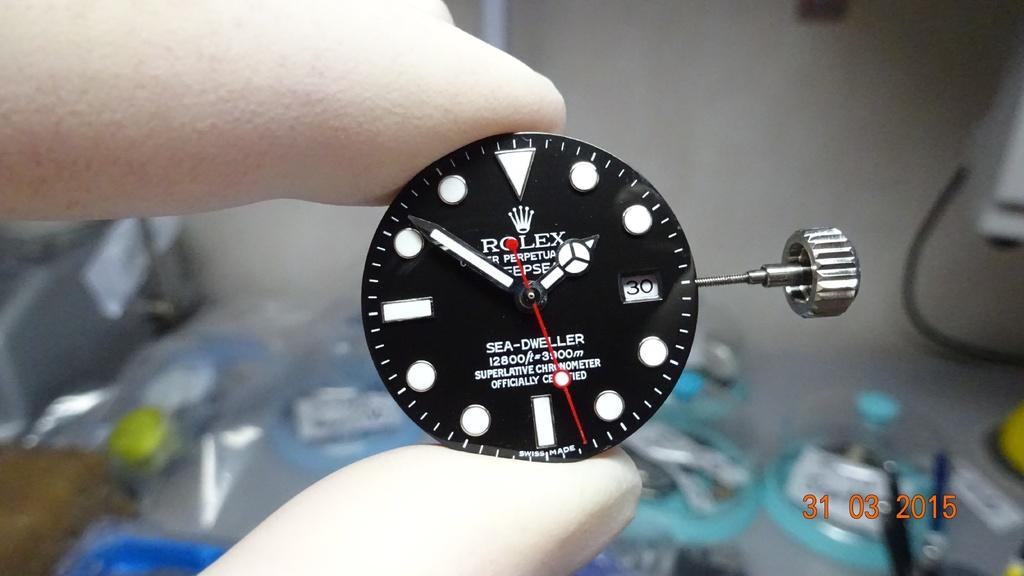<image>
Present a compact description of the photo's key features. Fingers hold up the front of a Rolex time piece with the time of 1:51. 